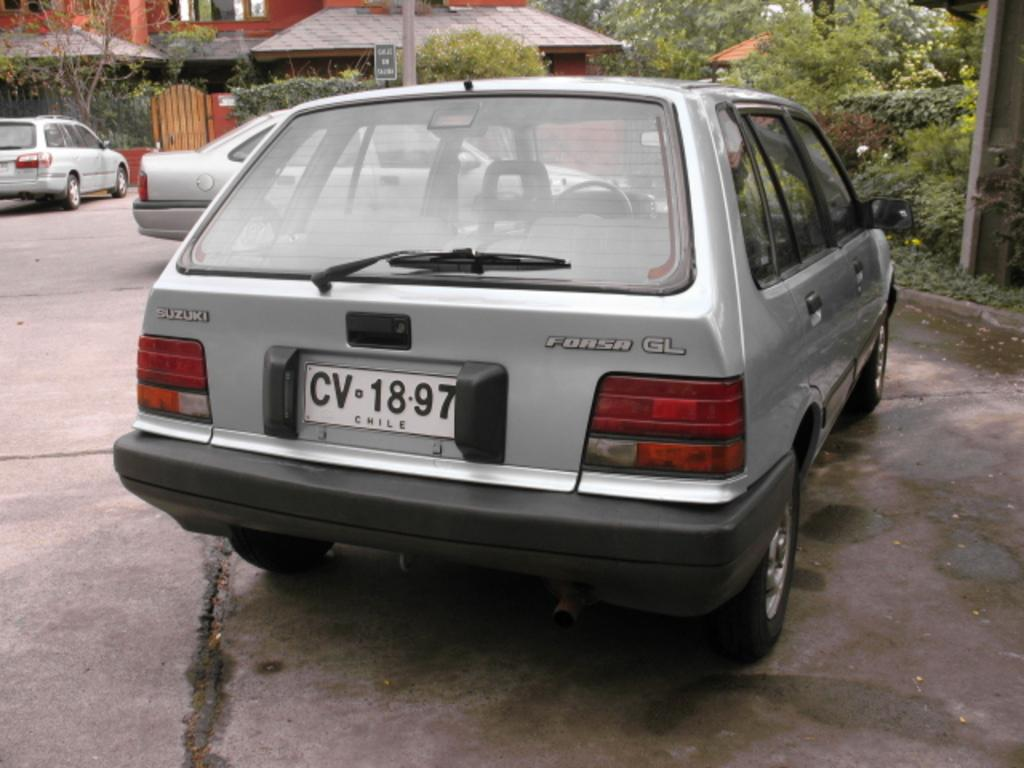<image>
Give a short and clear explanation of the subsequent image. A silver car has a license plate that reads CV1897. 